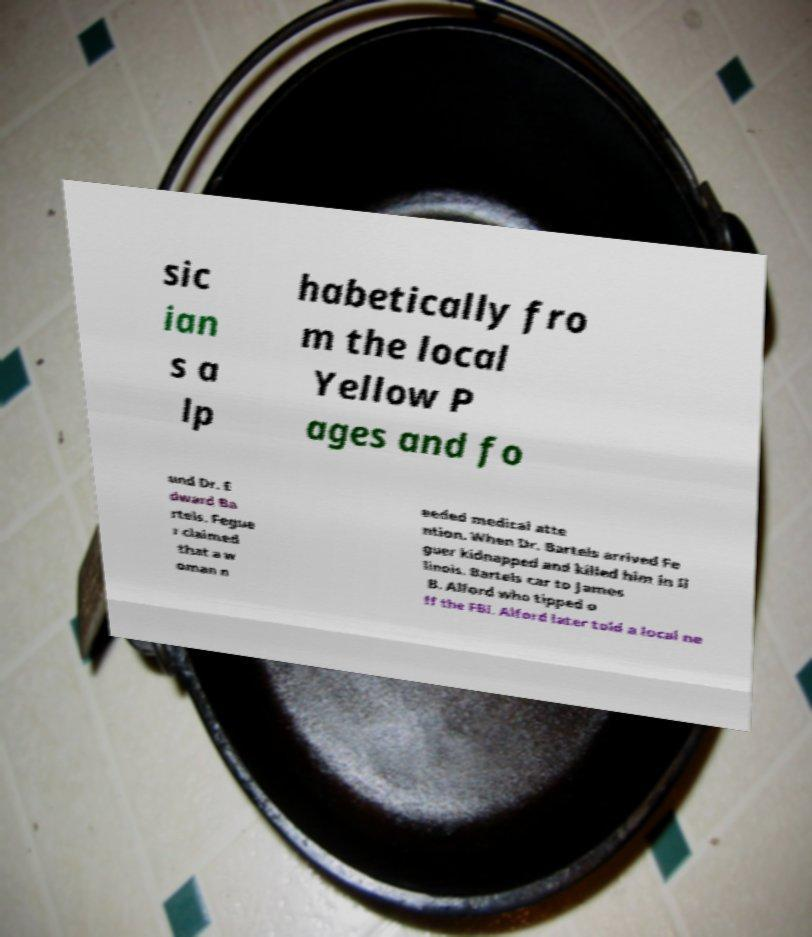Could you assist in decoding the text presented in this image and type it out clearly? sic ian s a lp habetically fro m the local Yellow P ages and fo und Dr. E dward Ba rtels. Fegue r claimed that a w oman n eeded medical atte ntion. When Dr. Bartels arrived Fe guer kidnapped and killed him in Il linois. Bartels car to James B. Alford who tipped o ff the FBI. Alford later told a local ne 